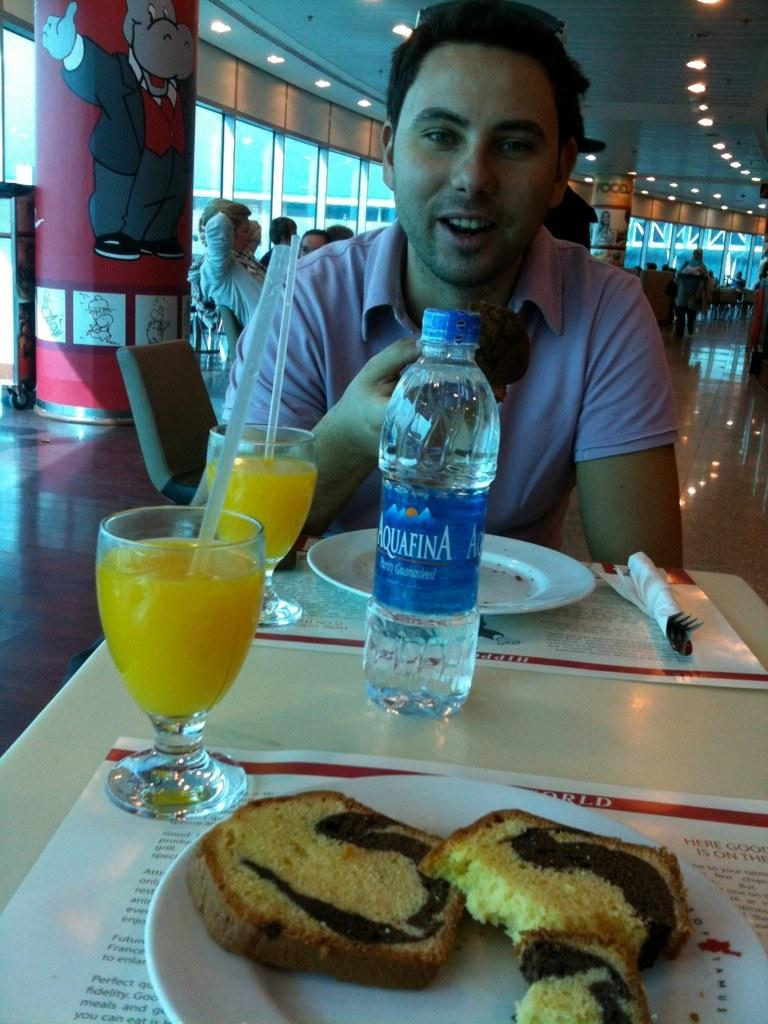What can be seen in the image? There is a person in the image. What is the person wearing? The person is wearing a pink shirt. What is the person doing in the image? The person is eating something. What is on the table in front of the person? There is a water bottle, juice, and bread on the table. Are there any other people in the image? Yes, there is a group of people behind the person. What type of horn can be heard in the image? There is no horn present in the image, and therefore no sound can be heard. What impulse might the person be experiencing while eating? It is not possible to determine the person's impulses from the image alone. What belief system might the group of people behind the person follow? There is no information about the group's belief system in the image. 